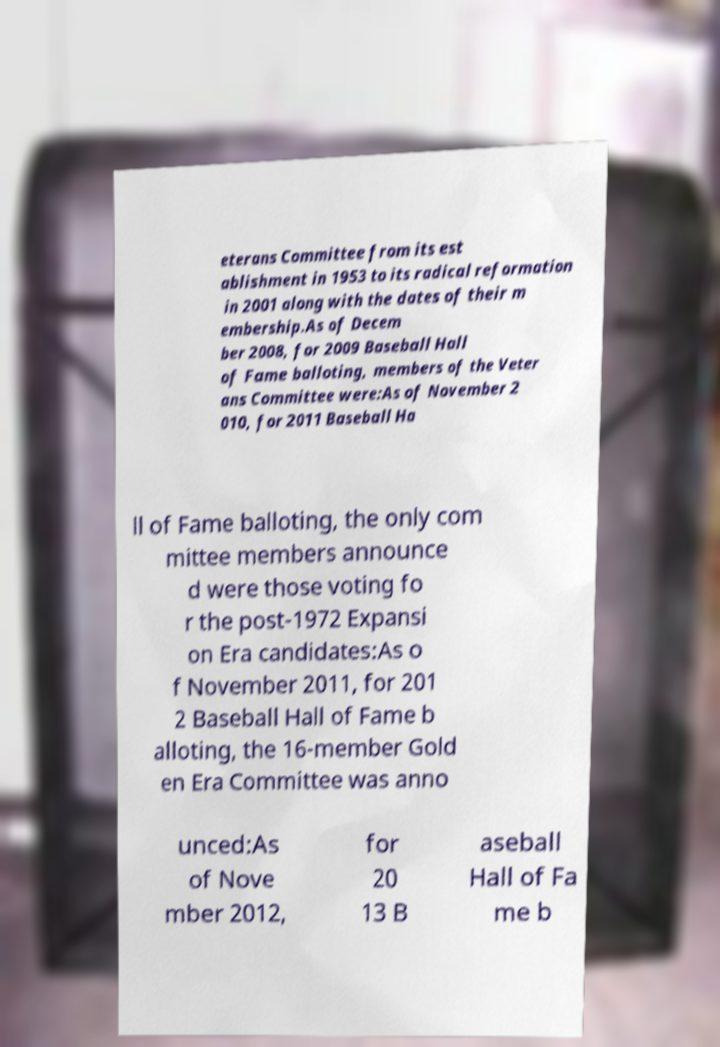There's text embedded in this image that I need extracted. Can you transcribe it verbatim? eterans Committee from its est ablishment in 1953 to its radical reformation in 2001 along with the dates of their m embership.As of Decem ber 2008, for 2009 Baseball Hall of Fame balloting, members of the Veter ans Committee were:As of November 2 010, for 2011 Baseball Ha ll of Fame balloting, the only com mittee members announce d were those voting fo r the post-1972 Expansi on Era candidates:As o f November 2011, for 201 2 Baseball Hall of Fame b alloting, the 16-member Gold en Era Committee was anno unced:As of Nove mber 2012, for 20 13 B aseball Hall of Fa me b 